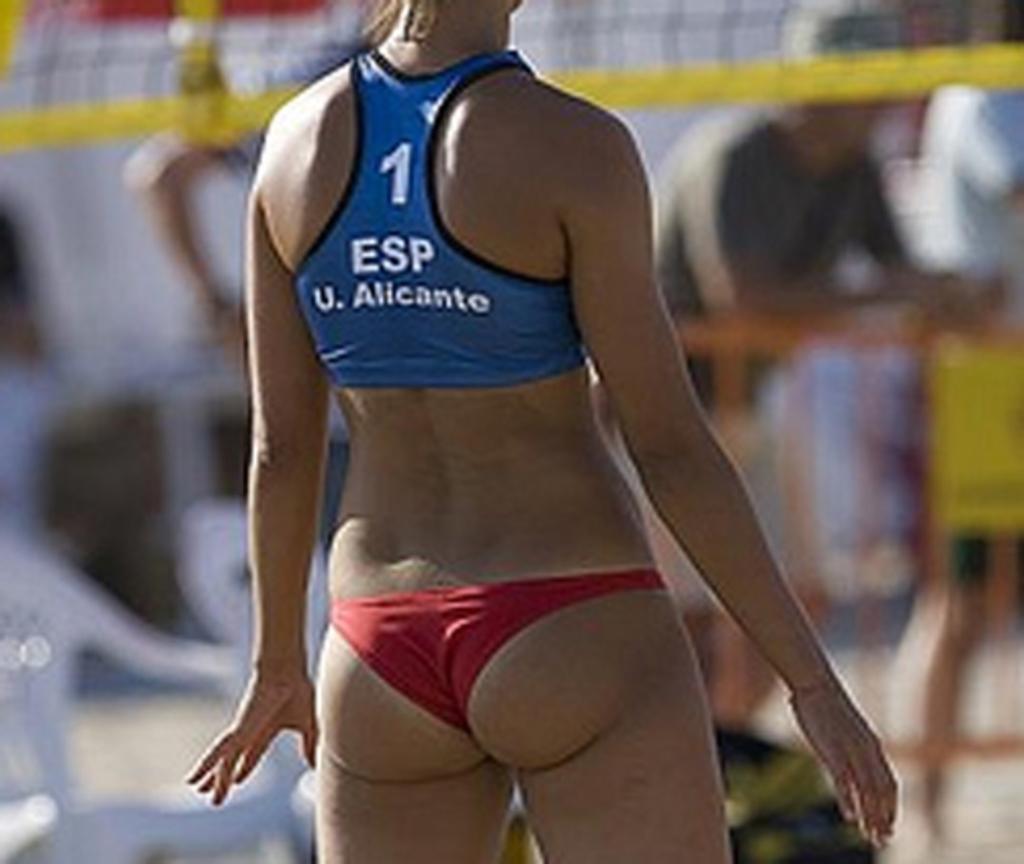What player is this?
Offer a terse response. 1. What is this player's number?
Offer a very short reply. 1. 